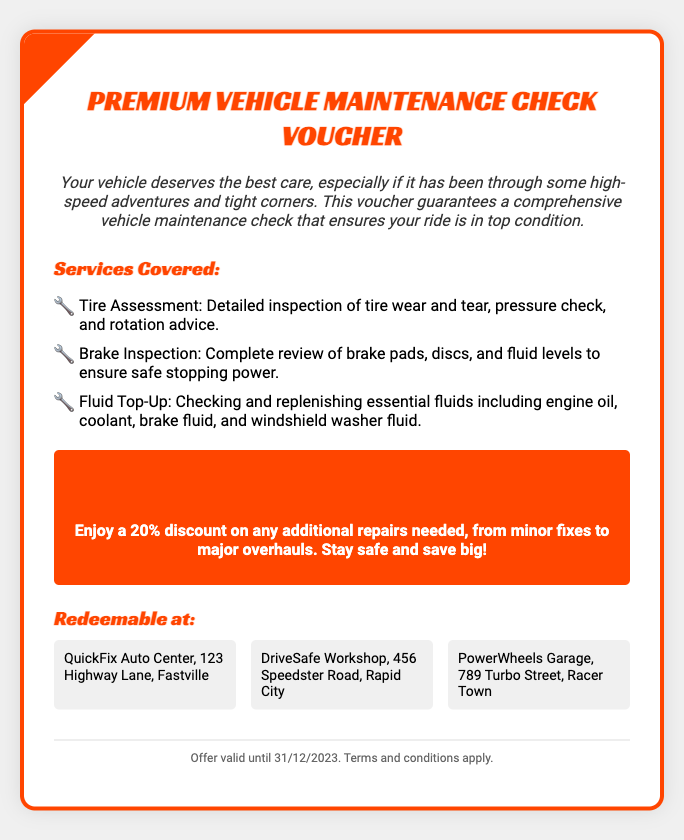What is the title of the voucher? The title of the voucher is prominently displayed at the top of the document.
Answer: Premium Vehicle Maintenance Check Voucher What services are included in the maintenance check? The document lists services under "Services Covered" which provides detailed inspection areas.
Answer: Tire Assessment, Brake Inspection, Fluid Top-Up What is the discount offered on additional repairs? The voucher specifies the percentage discount for any extra services needed.
Answer: 20% Where can the voucher be redeemed? The document lists locations where the voucher can be utilized.
Answer: QuickFix Auto Center, DriveSafe Workshop, PowerWheels Garage What is the expiration date of the offer? The footer section includes the validity period of the voucher.
Answer: 31/12/2023 Why might someone want to use this voucher? The introduction hints at the benefits of using this service, particularly for vehicles that have been driven intensively.
Answer: Ensure vehicle is in top condition 